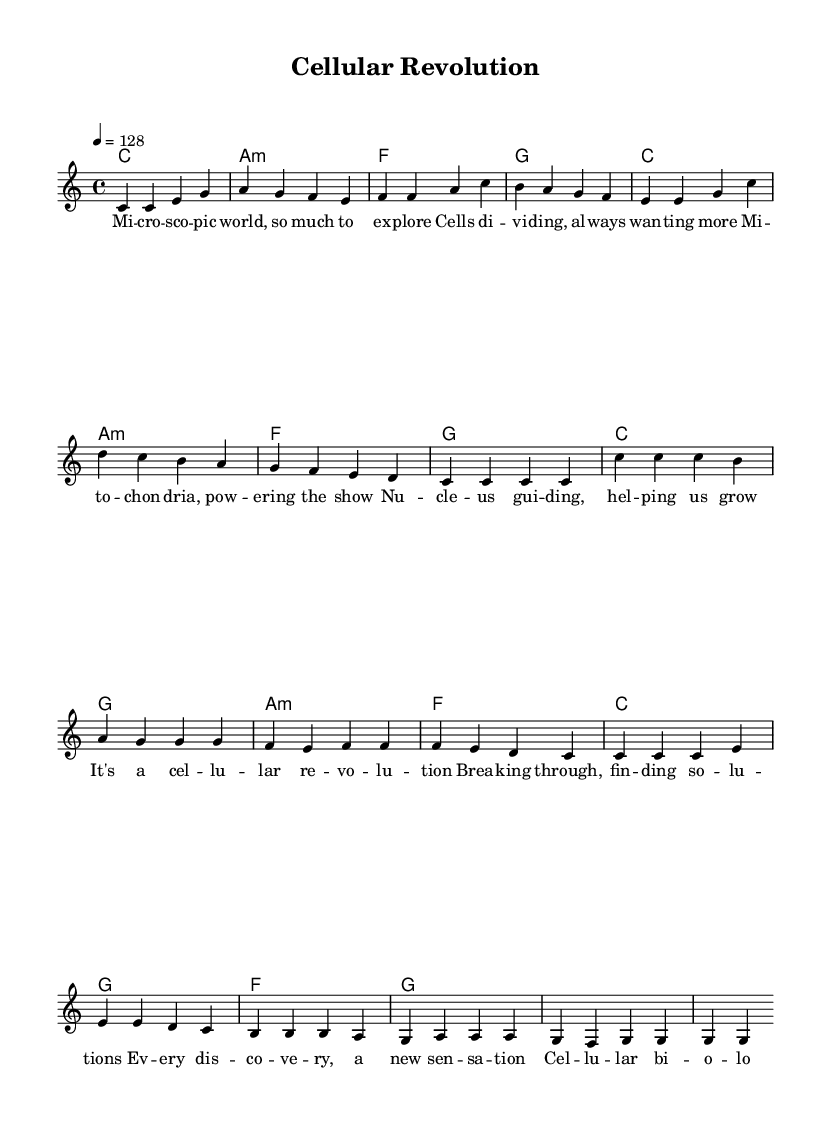What is the key signature of this music? The key signature indicated at the beginning of the music is C major, which is represented by the absence of any sharps or flats.
Answer: C major What is the time signature of this music? The time signature shown at the beginning of the score is 4/4, which means there are four beats in each measure and the quarter note receives one beat.
Answer: 4/4 What is the tempo marking of this music? The tempo marking specifies a beat of 128 beats per minute, denoted in the score with "4 = 128", indicating that each quarter note gets one beat at this speed.
Answer: 128 How many measures are in the verse section? Counting the measure bars, there are 8 measures indicated in the verse section as shown in the score.
Answer: 8 What is the main theme of the chorus lyrics? The chorus lyrics emphasize the excitement and discoveries in cellular biology, referring to it as a "cellular revolution." This central theme aligns with scientific breakthroughs and medical discoveries.
Answer: Cellular revolution Which chord is used in the first measure of the verse? The first measure of the verse indicates a C major chord, which is represented as "c1" in the chord mode section.
Answer: C What note is sustained through the last measure of the chorus? In the last measure of the chorus, the melody indicates the note G being sustained, as shown in the corresponding notation.
Answer: G 